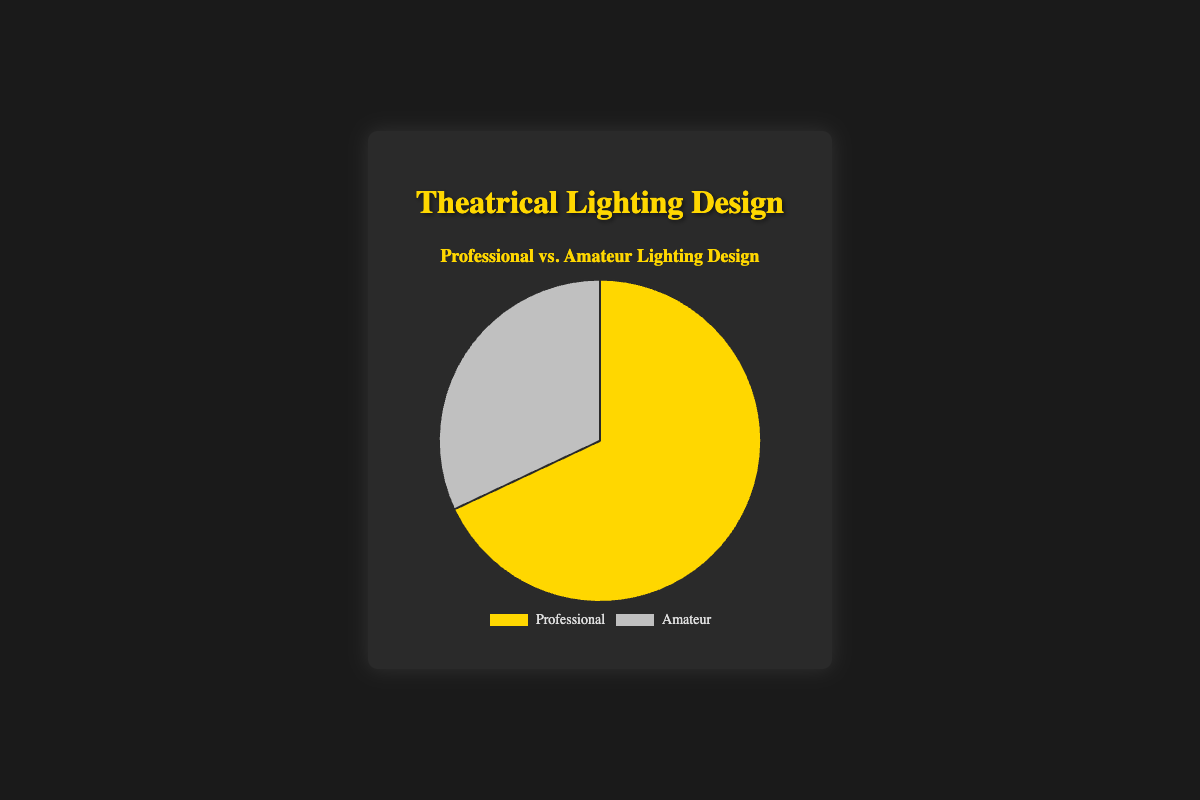what percentage of performances use professional lighting design? The figure shows a pie chart with labels for each category. One section is labeled "Professional," and it has a percentage value of 68%.
Answer: 68% what is the visual difference between the professional and amateur sections of the pie chart? The pie chart segments representing "Professional" and "Amateur" have different colors and sizes. The "Professional" section is golden yellow and larger, taking up 68% of the chart, while the "Amateur" section is silver and smaller, occupying 32%.
Answer: golden yellow and larger which type of lighting design is more common in performances? The pie chart shows two categories: "Professional" and "Amateur." The "Professional" section is larger, indicating that a greater percentage of performances use professional lighting design.
Answer: Professional how much larger is the percentage of professional lighting design compared to amateur lighting design? The chart indicates professional lighting is 68% and amateur lighting is 32%: 68 - 32 = 36. Therefore, professional lighting design is 36% larger.
Answer: 36% what proportion of performances use amateur lighting design? The pie chart shows an "Amateur" section labeled with a percentage of 32%. This indicates that 32% of performances use amateur lighting design.
Answer: 32% if the total number of performances is 100, how many of them have professional lighting design? The pie chart indicates that 68% of performances use professional lighting. If there are 100 performances in total: 100 * 0.68 = 68 performances have professional lighting design.
Answer: 68 if the total number of performances is 200, how many of them have amateur lighting design? The chart shows that 32% of performances use amateur lighting. For 200 total performances: 200 * 0.32 = 64 performances use amateur lighting design.
Answer: 64 